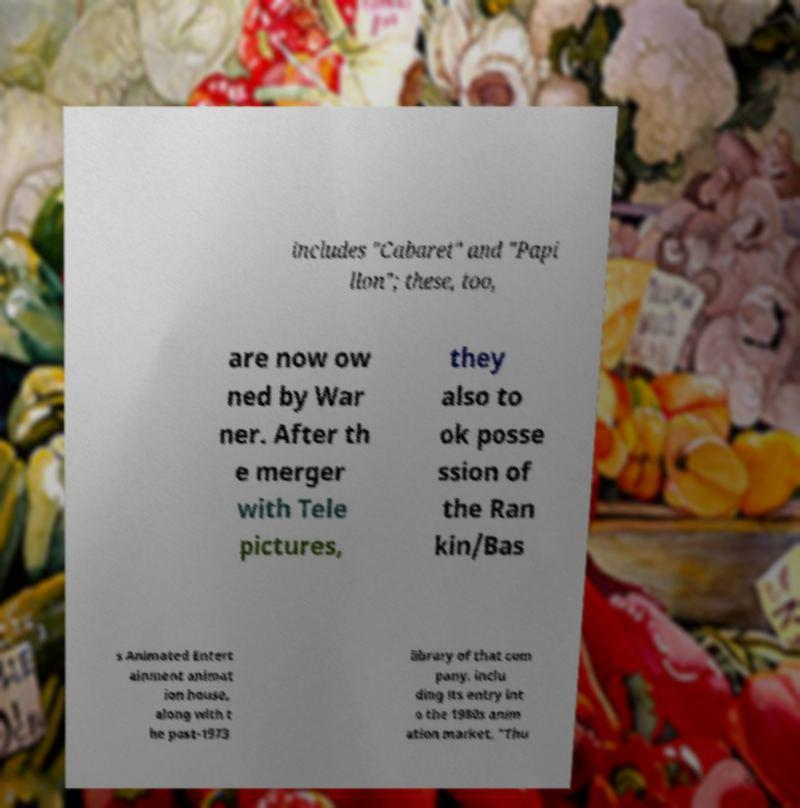There's text embedded in this image that I need extracted. Can you transcribe it verbatim? includes "Cabaret" and "Papi llon"; these, too, are now ow ned by War ner. After th e merger with Tele pictures, they also to ok posse ssion of the Ran kin/Bas s Animated Entert ainment animat ion house, along with t he post-1973 library of that com pany, inclu ding its entry int o the 1980s anim ation market, "Thu 